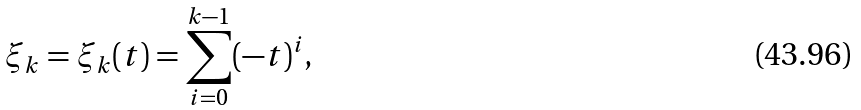Convert formula to latex. <formula><loc_0><loc_0><loc_500><loc_500>\xi _ { k } = \xi _ { k } ( t ) = \sum ^ { k - 1 } _ { i = 0 } ( - t ) ^ { i } ,</formula> 